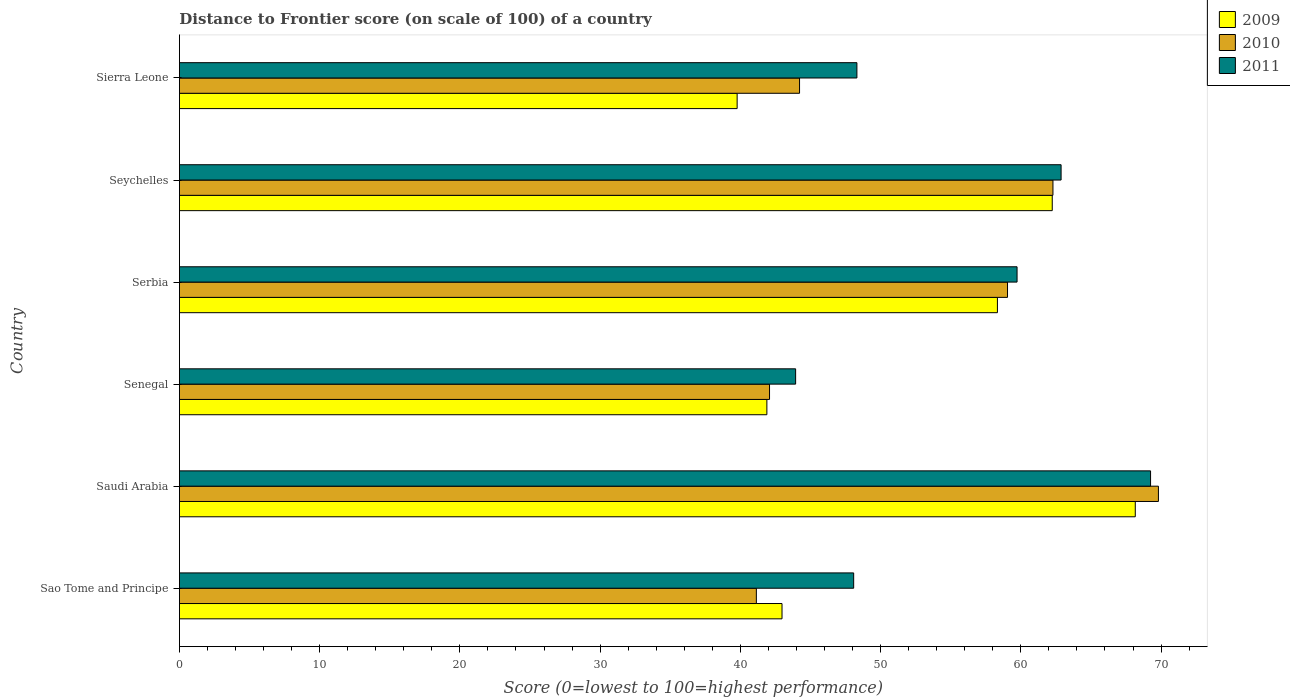How many groups of bars are there?
Give a very brief answer. 6. Are the number of bars on each tick of the Y-axis equal?
Provide a succinct answer. Yes. How many bars are there on the 2nd tick from the top?
Provide a succinct answer. 3. What is the label of the 1st group of bars from the top?
Provide a short and direct response. Sierra Leone. In how many cases, is the number of bars for a given country not equal to the number of legend labels?
Keep it short and to the point. 0. What is the distance to frontier score of in 2010 in Sierra Leone?
Your answer should be compact. 44.22. Across all countries, what is the maximum distance to frontier score of in 2010?
Your answer should be very brief. 69.81. Across all countries, what is the minimum distance to frontier score of in 2009?
Your answer should be very brief. 39.77. In which country was the distance to frontier score of in 2011 maximum?
Make the answer very short. Saudi Arabia. In which country was the distance to frontier score of in 2009 minimum?
Offer a terse response. Sierra Leone. What is the total distance to frontier score of in 2011 in the graph?
Offer a very short reply. 332.18. What is the difference between the distance to frontier score of in 2010 in Saudi Arabia and that in Serbia?
Ensure brevity in your answer.  10.76. What is the difference between the distance to frontier score of in 2010 in Saudi Arabia and the distance to frontier score of in 2009 in Seychelles?
Keep it short and to the point. 7.57. What is the average distance to frontier score of in 2009 per country?
Offer a terse response. 52.23. What is the difference between the distance to frontier score of in 2009 and distance to frontier score of in 2011 in Seychelles?
Your answer should be compact. -0.63. In how many countries, is the distance to frontier score of in 2010 greater than 34 ?
Provide a succinct answer. 6. What is the ratio of the distance to frontier score of in 2011 in Sao Tome and Principe to that in Senegal?
Make the answer very short. 1.09. What is the difference between the highest and the second highest distance to frontier score of in 2010?
Offer a very short reply. 7.52. What is the difference between the highest and the lowest distance to frontier score of in 2009?
Provide a succinct answer. 28.39. What does the 3rd bar from the top in Seychelles represents?
Keep it short and to the point. 2009. Are the values on the major ticks of X-axis written in scientific E-notation?
Your answer should be compact. No. Does the graph contain grids?
Provide a short and direct response. No. Where does the legend appear in the graph?
Make the answer very short. Top right. How are the legend labels stacked?
Give a very brief answer. Vertical. What is the title of the graph?
Ensure brevity in your answer.  Distance to Frontier score (on scale of 100) of a country. Does "2002" appear as one of the legend labels in the graph?
Your answer should be compact. No. What is the label or title of the X-axis?
Provide a short and direct response. Score (0=lowest to 100=highest performance). What is the label or title of the Y-axis?
Offer a terse response. Country. What is the Score (0=lowest to 100=highest performance) in 2009 in Sao Tome and Principe?
Keep it short and to the point. 42.97. What is the Score (0=lowest to 100=highest performance) of 2010 in Sao Tome and Principe?
Your answer should be very brief. 41.14. What is the Score (0=lowest to 100=highest performance) in 2011 in Sao Tome and Principe?
Your response must be concise. 48.08. What is the Score (0=lowest to 100=highest performance) in 2009 in Saudi Arabia?
Offer a very short reply. 68.16. What is the Score (0=lowest to 100=highest performance) of 2010 in Saudi Arabia?
Keep it short and to the point. 69.81. What is the Score (0=lowest to 100=highest performance) in 2011 in Saudi Arabia?
Offer a terse response. 69.25. What is the Score (0=lowest to 100=highest performance) in 2009 in Senegal?
Your answer should be compact. 41.89. What is the Score (0=lowest to 100=highest performance) in 2010 in Senegal?
Your answer should be very brief. 42.08. What is the Score (0=lowest to 100=highest performance) of 2011 in Senegal?
Offer a very short reply. 43.94. What is the Score (0=lowest to 100=highest performance) of 2009 in Serbia?
Your answer should be very brief. 58.33. What is the Score (0=lowest to 100=highest performance) in 2010 in Serbia?
Your answer should be very brief. 59.05. What is the Score (0=lowest to 100=highest performance) in 2011 in Serbia?
Make the answer very short. 59.73. What is the Score (0=lowest to 100=highest performance) of 2009 in Seychelles?
Offer a terse response. 62.24. What is the Score (0=lowest to 100=highest performance) of 2010 in Seychelles?
Provide a short and direct response. 62.29. What is the Score (0=lowest to 100=highest performance) of 2011 in Seychelles?
Offer a terse response. 62.87. What is the Score (0=lowest to 100=highest performance) in 2009 in Sierra Leone?
Your answer should be compact. 39.77. What is the Score (0=lowest to 100=highest performance) of 2010 in Sierra Leone?
Your answer should be compact. 44.22. What is the Score (0=lowest to 100=highest performance) of 2011 in Sierra Leone?
Provide a succinct answer. 48.31. Across all countries, what is the maximum Score (0=lowest to 100=highest performance) of 2009?
Provide a succinct answer. 68.16. Across all countries, what is the maximum Score (0=lowest to 100=highest performance) in 2010?
Your answer should be compact. 69.81. Across all countries, what is the maximum Score (0=lowest to 100=highest performance) in 2011?
Provide a succinct answer. 69.25. Across all countries, what is the minimum Score (0=lowest to 100=highest performance) of 2009?
Offer a very short reply. 39.77. Across all countries, what is the minimum Score (0=lowest to 100=highest performance) in 2010?
Offer a very short reply. 41.14. Across all countries, what is the minimum Score (0=lowest to 100=highest performance) in 2011?
Give a very brief answer. 43.94. What is the total Score (0=lowest to 100=highest performance) of 2009 in the graph?
Your answer should be very brief. 313.36. What is the total Score (0=lowest to 100=highest performance) in 2010 in the graph?
Offer a terse response. 318.59. What is the total Score (0=lowest to 100=highest performance) of 2011 in the graph?
Your answer should be very brief. 332.18. What is the difference between the Score (0=lowest to 100=highest performance) of 2009 in Sao Tome and Principe and that in Saudi Arabia?
Offer a terse response. -25.19. What is the difference between the Score (0=lowest to 100=highest performance) in 2010 in Sao Tome and Principe and that in Saudi Arabia?
Your answer should be compact. -28.67. What is the difference between the Score (0=lowest to 100=highest performance) in 2011 in Sao Tome and Principe and that in Saudi Arabia?
Keep it short and to the point. -21.17. What is the difference between the Score (0=lowest to 100=highest performance) in 2009 in Sao Tome and Principe and that in Senegal?
Provide a short and direct response. 1.08. What is the difference between the Score (0=lowest to 100=highest performance) of 2010 in Sao Tome and Principe and that in Senegal?
Your response must be concise. -0.94. What is the difference between the Score (0=lowest to 100=highest performance) of 2011 in Sao Tome and Principe and that in Senegal?
Keep it short and to the point. 4.14. What is the difference between the Score (0=lowest to 100=highest performance) of 2009 in Sao Tome and Principe and that in Serbia?
Provide a succinct answer. -15.36. What is the difference between the Score (0=lowest to 100=highest performance) of 2010 in Sao Tome and Principe and that in Serbia?
Your answer should be compact. -17.91. What is the difference between the Score (0=lowest to 100=highest performance) of 2011 in Sao Tome and Principe and that in Serbia?
Keep it short and to the point. -11.65. What is the difference between the Score (0=lowest to 100=highest performance) in 2009 in Sao Tome and Principe and that in Seychelles?
Offer a terse response. -19.27. What is the difference between the Score (0=lowest to 100=highest performance) of 2010 in Sao Tome and Principe and that in Seychelles?
Give a very brief answer. -21.15. What is the difference between the Score (0=lowest to 100=highest performance) in 2011 in Sao Tome and Principe and that in Seychelles?
Give a very brief answer. -14.79. What is the difference between the Score (0=lowest to 100=highest performance) in 2010 in Sao Tome and Principe and that in Sierra Leone?
Your answer should be very brief. -3.08. What is the difference between the Score (0=lowest to 100=highest performance) of 2011 in Sao Tome and Principe and that in Sierra Leone?
Provide a short and direct response. -0.23. What is the difference between the Score (0=lowest to 100=highest performance) of 2009 in Saudi Arabia and that in Senegal?
Your answer should be very brief. 26.27. What is the difference between the Score (0=lowest to 100=highest performance) in 2010 in Saudi Arabia and that in Senegal?
Offer a terse response. 27.73. What is the difference between the Score (0=lowest to 100=highest performance) in 2011 in Saudi Arabia and that in Senegal?
Your answer should be very brief. 25.31. What is the difference between the Score (0=lowest to 100=highest performance) of 2009 in Saudi Arabia and that in Serbia?
Your answer should be very brief. 9.83. What is the difference between the Score (0=lowest to 100=highest performance) of 2010 in Saudi Arabia and that in Serbia?
Offer a terse response. 10.76. What is the difference between the Score (0=lowest to 100=highest performance) in 2011 in Saudi Arabia and that in Serbia?
Your response must be concise. 9.52. What is the difference between the Score (0=lowest to 100=highest performance) of 2009 in Saudi Arabia and that in Seychelles?
Offer a terse response. 5.92. What is the difference between the Score (0=lowest to 100=highest performance) in 2010 in Saudi Arabia and that in Seychelles?
Your answer should be compact. 7.52. What is the difference between the Score (0=lowest to 100=highest performance) of 2011 in Saudi Arabia and that in Seychelles?
Ensure brevity in your answer.  6.38. What is the difference between the Score (0=lowest to 100=highest performance) of 2009 in Saudi Arabia and that in Sierra Leone?
Make the answer very short. 28.39. What is the difference between the Score (0=lowest to 100=highest performance) in 2010 in Saudi Arabia and that in Sierra Leone?
Ensure brevity in your answer.  25.59. What is the difference between the Score (0=lowest to 100=highest performance) of 2011 in Saudi Arabia and that in Sierra Leone?
Provide a succinct answer. 20.94. What is the difference between the Score (0=lowest to 100=highest performance) of 2009 in Senegal and that in Serbia?
Keep it short and to the point. -16.44. What is the difference between the Score (0=lowest to 100=highest performance) in 2010 in Senegal and that in Serbia?
Provide a short and direct response. -16.97. What is the difference between the Score (0=lowest to 100=highest performance) in 2011 in Senegal and that in Serbia?
Provide a short and direct response. -15.79. What is the difference between the Score (0=lowest to 100=highest performance) in 2009 in Senegal and that in Seychelles?
Make the answer very short. -20.35. What is the difference between the Score (0=lowest to 100=highest performance) in 2010 in Senegal and that in Seychelles?
Your answer should be very brief. -20.21. What is the difference between the Score (0=lowest to 100=highest performance) of 2011 in Senegal and that in Seychelles?
Make the answer very short. -18.93. What is the difference between the Score (0=lowest to 100=highest performance) in 2009 in Senegal and that in Sierra Leone?
Offer a terse response. 2.12. What is the difference between the Score (0=lowest to 100=highest performance) in 2010 in Senegal and that in Sierra Leone?
Your answer should be very brief. -2.14. What is the difference between the Score (0=lowest to 100=highest performance) in 2011 in Senegal and that in Sierra Leone?
Make the answer very short. -4.37. What is the difference between the Score (0=lowest to 100=highest performance) of 2009 in Serbia and that in Seychelles?
Offer a terse response. -3.91. What is the difference between the Score (0=lowest to 100=highest performance) in 2010 in Serbia and that in Seychelles?
Offer a very short reply. -3.24. What is the difference between the Score (0=lowest to 100=highest performance) in 2011 in Serbia and that in Seychelles?
Make the answer very short. -3.14. What is the difference between the Score (0=lowest to 100=highest performance) in 2009 in Serbia and that in Sierra Leone?
Give a very brief answer. 18.56. What is the difference between the Score (0=lowest to 100=highest performance) of 2010 in Serbia and that in Sierra Leone?
Offer a terse response. 14.83. What is the difference between the Score (0=lowest to 100=highest performance) in 2011 in Serbia and that in Sierra Leone?
Ensure brevity in your answer.  11.42. What is the difference between the Score (0=lowest to 100=highest performance) in 2009 in Seychelles and that in Sierra Leone?
Provide a short and direct response. 22.47. What is the difference between the Score (0=lowest to 100=highest performance) of 2010 in Seychelles and that in Sierra Leone?
Your response must be concise. 18.07. What is the difference between the Score (0=lowest to 100=highest performance) in 2011 in Seychelles and that in Sierra Leone?
Your answer should be compact. 14.56. What is the difference between the Score (0=lowest to 100=highest performance) in 2009 in Sao Tome and Principe and the Score (0=lowest to 100=highest performance) in 2010 in Saudi Arabia?
Offer a terse response. -26.84. What is the difference between the Score (0=lowest to 100=highest performance) of 2009 in Sao Tome and Principe and the Score (0=lowest to 100=highest performance) of 2011 in Saudi Arabia?
Your answer should be compact. -26.28. What is the difference between the Score (0=lowest to 100=highest performance) of 2010 in Sao Tome and Principe and the Score (0=lowest to 100=highest performance) of 2011 in Saudi Arabia?
Ensure brevity in your answer.  -28.11. What is the difference between the Score (0=lowest to 100=highest performance) in 2009 in Sao Tome and Principe and the Score (0=lowest to 100=highest performance) in 2010 in Senegal?
Keep it short and to the point. 0.89. What is the difference between the Score (0=lowest to 100=highest performance) of 2009 in Sao Tome and Principe and the Score (0=lowest to 100=highest performance) of 2011 in Senegal?
Your answer should be very brief. -0.97. What is the difference between the Score (0=lowest to 100=highest performance) of 2010 in Sao Tome and Principe and the Score (0=lowest to 100=highest performance) of 2011 in Senegal?
Your answer should be very brief. -2.8. What is the difference between the Score (0=lowest to 100=highest performance) of 2009 in Sao Tome and Principe and the Score (0=lowest to 100=highest performance) of 2010 in Serbia?
Your response must be concise. -16.08. What is the difference between the Score (0=lowest to 100=highest performance) of 2009 in Sao Tome and Principe and the Score (0=lowest to 100=highest performance) of 2011 in Serbia?
Your answer should be very brief. -16.76. What is the difference between the Score (0=lowest to 100=highest performance) of 2010 in Sao Tome and Principe and the Score (0=lowest to 100=highest performance) of 2011 in Serbia?
Give a very brief answer. -18.59. What is the difference between the Score (0=lowest to 100=highest performance) of 2009 in Sao Tome and Principe and the Score (0=lowest to 100=highest performance) of 2010 in Seychelles?
Give a very brief answer. -19.32. What is the difference between the Score (0=lowest to 100=highest performance) in 2009 in Sao Tome and Principe and the Score (0=lowest to 100=highest performance) in 2011 in Seychelles?
Make the answer very short. -19.9. What is the difference between the Score (0=lowest to 100=highest performance) of 2010 in Sao Tome and Principe and the Score (0=lowest to 100=highest performance) of 2011 in Seychelles?
Offer a very short reply. -21.73. What is the difference between the Score (0=lowest to 100=highest performance) of 2009 in Sao Tome and Principe and the Score (0=lowest to 100=highest performance) of 2010 in Sierra Leone?
Offer a very short reply. -1.25. What is the difference between the Score (0=lowest to 100=highest performance) in 2009 in Sao Tome and Principe and the Score (0=lowest to 100=highest performance) in 2011 in Sierra Leone?
Your response must be concise. -5.34. What is the difference between the Score (0=lowest to 100=highest performance) in 2010 in Sao Tome and Principe and the Score (0=lowest to 100=highest performance) in 2011 in Sierra Leone?
Provide a short and direct response. -7.17. What is the difference between the Score (0=lowest to 100=highest performance) in 2009 in Saudi Arabia and the Score (0=lowest to 100=highest performance) in 2010 in Senegal?
Your response must be concise. 26.08. What is the difference between the Score (0=lowest to 100=highest performance) of 2009 in Saudi Arabia and the Score (0=lowest to 100=highest performance) of 2011 in Senegal?
Offer a very short reply. 24.22. What is the difference between the Score (0=lowest to 100=highest performance) of 2010 in Saudi Arabia and the Score (0=lowest to 100=highest performance) of 2011 in Senegal?
Your answer should be very brief. 25.87. What is the difference between the Score (0=lowest to 100=highest performance) of 2009 in Saudi Arabia and the Score (0=lowest to 100=highest performance) of 2010 in Serbia?
Your answer should be very brief. 9.11. What is the difference between the Score (0=lowest to 100=highest performance) of 2009 in Saudi Arabia and the Score (0=lowest to 100=highest performance) of 2011 in Serbia?
Make the answer very short. 8.43. What is the difference between the Score (0=lowest to 100=highest performance) of 2010 in Saudi Arabia and the Score (0=lowest to 100=highest performance) of 2011 in Serbia?
Provide a succinct answer. 10.08. What is the difference between the Score (0=lowest to 100=highest performance) of 2009 in Saudi Arabia and the Score (0=lowest to 100=highest performance) of 2010 in Seychelles?
Make the answer very short. 5.87. What is the difference between the Score (0=lowest to 100=highest performance) of 2009 in Saudi Arabia and the Score (0=lowest to 100=highest performance) of 2011 in Seychelles?
Provide a short and direct response. 5.29. What is the difference between the Score (0=lowest to 100=highest performance) of 2010 in Saudi Arabia and the Score (0=lowest to 100=highest performance) of 2011 in Seychelles?
Your response must be concise. 6.94. What is the difference between the Score (0=lowest to 100=highest performance) in 2009 in Saudi Arabia and the Score (0=lowest to 100=highest performance) in 2010 in Sierra Leone?
Provide a succinct answer. 23.94. What is the difference between the Score (0=lowest to 100=highest performance) of 2009 in Saudi Arabia and the Score (0=lowest to 100=highest performance) of 2011 in Sierra Leone?
Your response must be concise. 19.85. What is the difference between the Score (0=lowest to 100=highest performance) of 2009 in Senegal and the Score (0=lowest to 100=highest performance) of 2010 in Serbia?
Provide a short and direct response. -17.16. What is the difference between the Score (0=lowest to 100=highest performance) of 2009 in Senegal and the Score (0=lowest to 100=highest performance) of 2011 in Serbia?
Your answer should be compact. -17.84. What is the difference between the Score (0=lowest to 100=highest performance) in 2010 in Senegal and the Score (0=lowest to 100=highest performance) in 2011 in Serbia?
Ensure brevity in your answer.  -17.65. What is the difference between the Score (0=lowest to 100=highest performance) of 2009 in Senegal and the Score (0=lowest to 100=highest performance) of 2010 in Seychelles?
Provide a short and direct response. -20.4. What is the difference between the Score (0=lowest to 100=highest performance) in 2009 in Senegal and the Score (0=lowest to 100=highest performance) in 2011 in Seychelles?
Give a very brief answer. -20.98. What is the difference between the Score (0=lowest to 100=highest performance) in 2010 in Senegal and the Score (0=lowest to 100=highest performance) in 2011 in Seychelles?
Offer a very short reply. -20.79. What is the difference between the Score (0=lowest to 100=highest performance) of 2009 in Senegal and the Score (0=lowest to 100=highest performance) of 2010 in Sierra Leone?
Ensure brevity in your answer.  -2.33. What is the difference between the Score (0=lowest to 100=highest performance) in 2009 in Senegal and the Score (0=lowest to 100=highest performance) in 2011 in Sierra Leone?
Keep it short and to the point. -6.42. What is the difference between the Score (0=lowest to 100=highest performance) of 2010 in Senegal and the Score (0=lowest to 100=highest performance) of 2011 in Sierra Leone?
Make the answer very short. -6.23. What is the difference between the Score (0=lowest to 100=highest performance) of 2009 in Serbia and the Score (0=lowest to 100=highest performance) of 2010 in Seychelles?
Keep it short and to the point. -3.96. What is the difference between the Score (0=lowest to 100=highest performance) in 2009 in Serbia and the Score (0=lowest to 100=highest performance) in 2011 in Seychelles?
Provide a short and direct response. -4.54. What is the difference between the Score (0=lowest to 100=highest performance) in 2010 in Serbia and the Score (0=lowest to 100=highest performance) in 2011 in Seychelles?
Offer a terse response. -3.82. What is the difference between the Score (0=lowest to 100=highest performance) of 2009 in Serbia and the Score (0=lowest to 100=highest performance) of 2010 in Sierra Leone?
Provide a succinct answer. 14.11. What is the difference between the Score (0=lowest to 100=highest performance) of 2009 in Serbia and the Score (0=lowest to 100=highest performance) of 2011 in Sierra Leone?
Your answer should be very brief. 10.02. What is the difference between the Score (0=lowest to 100=highest performance) of 2010 in Serbia and the Score (0=lowest to 100=highest performance) of 2011 in Sierra Leone?
Your answer should be very brief. 10.74. What is the difference between the Score (0=lowest to 100=highest performance) in 2009 in Seychelles and the Score (0=lowest to 100=highest performance) in 2010 in Sierra Leone?
Your response must be concise. 18.02. What is the difference between the Score (0=lowest to 100=highest performance) of 2009 in Seychelles and the Score (0=lowest to 100=highest performance) of 2011 in Sierra Leone?
Give a very brief answer. 13.93. What is the difference between the Score (0=lowest to 100=highest performance) of 2010 in Seychelles and the Score (0=lowest to 100=highest performance) of 2011 in Sierra Leone?
Your answer should be very brief. 13.98. What is the average Score (0=lowest to 100=highest performance) in 2009 per country?
Ensure brevity in your answer.  52.23. What is the average Score (0=lowest to 100=highest performance) of 2010 per country?
Provide a succinct answer. 53.1. What is the average Score (0=lowest to 100=highest performance) in 2011 per country?
Ensure brevity in your answer.  55.36. What is the difference between the Score (0=lowest to 100=highest performance) in 2009 and Score (0=lowest to 100=highest performance) in 2010 in Sao Tome and Principe?
Give a very brief answer. 1.83. What is the difference between the Score (0=lowest to 100=highest performance) of 2009 and Score (0=lowest to 100=highest performance) of 2011 in Sao Tome and Principe?
Provide a short and direct response. -5.11. What is the difference between the Score (0=lowest to 100=highest performance) in 2010 and Score (0=lowest to 100=highest performance) in 2011 in Sao Tome and Principe?
Make the answer very short. -6.94. What is the difference between the Score (0=lowest to 100=highest performance) in 2009 and Score (0=lowest to 100=highest performance) in 2010 in Saudi Arabia?
Offer a terse response. -1.65. What is the difference between the Score (0=lowest to 100=highest performance) in 2009 and Score (0=lowest to 100=highest performance) in 2011 in Saudi Arabia?
Give a very brief answer. -1.09. What is the difference between the Score (0=lowest to 100=highest performance) of 2010 and Score (0=lowest to 100=highest performance) of 2011 in Saudi Arabia?
Offer a terse response. 0.56. What is the difference between the Score (0=lowest to 100=highest performance) of 2009 and Score (0=lowest to 100=highest performance) of 2010 in Senegal?
Offer a terse response. -0.19. What is the difference between the Score (0=lowest to 100=highest performance) of 2009 and Score (0=lowest to 100=highest performance) of 2011 in Senegal?
Keep it short and to the point. -2.05. What is the difference between the Score (0=lowest to 100=highest performance) in 2010 and Score (0=lowest to 100=highest performance) in 2011 in Senegal?
Offer a terse response. -1.86. What is the difference between the Score (0=lowest to 100=highest performance) of 2009 and Score (0=lowest to 100=highest performance) of 2010 in Serbia?
Keep it short and to the point. -0.72. What is the difference between the Score (0=lowest to 100=highest performance) in 2010 and Score (0=lowest to 100=highest performance) in 2011 in Serbia?
Provide a short and direct response. -0.68. What is the difference between the Score (0=lowest to 100=highest performance) in 2009 and Score (0=lowest to 100=highest performance) in 2011 in Seychelles?
Provide a succinct answer. -0.63. What is the difference between the Score (0=lowest to 100=highest performance) in 2010 and Score (0=lowest to 100=highest performance) in 2011 in Seychelles?
Your response must be concise. -0.58. What is the difference between the Score (0=lowest to 100=highest performance) in 2009 and Score (0=lowest to 100=highest performance) in 2010 in Sierra Leone?
Offer a terse response. -4.45. What is the difference between the Score (0=lowest to 100=highest performance) in 2009 and Score (0=lowest to 100=highest performance) in 2011 in Sierra Leone?
Your response must be concise. -8.54. What is the difference between the Score (0=lowest to 100=highest performance) of 2010 and Score (0=lowest to 100=highest performance) of 2011 in Sierra Leone?
Keep it short and to the point. -4.09. What is the ratio of the Score (0=lowest to 100=highest performance) in 2009 in Sao Tome and Principe to that in Saudi Arabia?
Make the answer very short. 0.63. What is the ratio of the Score (0=lowest to 100=highest performance) of 2010 in Sao Tome and Principe to that in Saudi Arabia?
Your answer should be compact. 0.59. What is the ratio of the Score (0=lowest to 100=highest performance) of 2011 in Sao Tome and Principe to that in Saudi Arabia?
Keep it short and to the point. 0.69. What is the ratio of the Score (0=lowest to 100=highest performance) of 2009 in Sao Tome and Principe to that in Senegal?
Offer a very short reply. 1.03. What is the ratio of the Score (0=lowest to 100=highest performance) of 2010 in Sao Tome and Principe to that in Senegal?
Your response must be concise. 0.98. What is the ratio of the Score (0=lowest to 100=highest performance) of 2011 in Sao Tome and Principe to that in Senegal?
Provide a short and direct response. 1.09. What is the ratio of the Score (0=lowest to 100=highest performance) of 2009 in Sao Tome and Principe to that in Serbia?
Keep it short and to the point. 0.74. What is the ratio of the Score (0=lowest to 100=highest performance) in 2010 in Sao Tome and Principe to that in Serbia?
Your answer should be compact. 0.7. What is the ratio of the Score (0=lowest to 100=highest performance) of 2011 in Sao Tome and Principe to that in Serbia?
Your response must be concise. 0.81. What is the ratio of the Score (0=lowest to 100=highest performance) in 2009 in Sao Tome and Principe to that in Seychelles?
Offer a very short reply. 0.69. What is the ratio of the Score (0=lowest to 100=highest performance) in 2010 in Sao Tome and Principe to that in Seychelles?
Your response must be concise. 0.66. What is the ratio of the Score (0=lowest to 100=highest performance) of 2011 in Sao Tome and Principe to that in Seychelles?
Keep it short and to the point. 0.76. What is the ratio of the Score (0=lowest to 100=highest performance) in 2009 in Sao Tome and Principe to that in Sierra Leone?
Offer a terse response. 1.08. What is the ratio of the Score (0=lowest to 100=highest performance) of 2010 in Sao Tome and Principe to that in Sierra Leone?
Your response must be concise. 0.93. What is the ratio of the Score (0=lowest to 100=highest performance) of 2011 in Sao Tome and Principe to that in Sierra Leone?
Your answer should be compact. 1. What is the ratio of the Score (0=lowest to 100=highest performance) of 2009 in Saudi Arabia to that in Senegal?
Your response must be concise. 1.63. What is the ratio of the Score (0=lowest to 100=highest performance) of 2010 in Saudi Arabia to that in Senegal?
Provide a succinct answer. 1.66. What is the ratio of the Score (0=lowest to 100=highest performance) of 2011 in Saudi Arabia to that in Senegal?
Provide a short and direct response. 1.58. What is the ratio of the Score (0=lowest to 100=highest performance) in 2009 in Saudi Arabia to that in Serbia?
Offer a terse response. 1.17. What is the ratio of the Score (0=lowest to 100=highest performance) in 2010 in Saudi Arabia to that in Serbia?
Ensure brevity in your answer.  1.18. What is the ratio of the Score (0=lowest to 100=highest performance) in 2011 in Saudi Arabia to that in Serbia?
Provide a succinct answer. 1.16. What is the ratio of the Score (0=lowest to 100=highest performance) in 2009 in Saudi Arabia to that in Seychelles?
Provide a succinct answer. 1.1. What is the ratio of the Score (0=lowest to 100=highest performance) of 2010 in Saudi Arabia to that in Seychelles?
Your response must be concise. 1.12. What is the ratio of the Score (0=lowest to 100=highest performance) of 2011 in Saudi Arabia to that in Seychelles?
Offer a very short reply. 1.1. What is the ratio of the Score (0=lowest to 100=highest performance) of 2009 in Saudi Arabia to that in Sierra Leone?
Your answer should be very brief. 1.71. What is the ratio of the Score (0=lowest to 100=highest performance) of 2010 in Saudi Arabia to that in Sierra Leone?
Provide a short and direct response. 1.58. What is the ratio of the Score (0=lowest to 100=highest performance) of 2011 in Saudi Arabia to that in Sierra Leone?
Give a very brief answer. 1.43. What is the ratio of the Score (0=lowest to 100=highest performance) of 2009 in Senegal to that in Serbia?
Provide a succinct answer. 0.72. What is the ratio of the Score (0=lowest to 100=highest performance) of 2010 in Senegal to that in Serbia?
Provide a short and direct response. 0.71. What is the ratio of the Score (0=lowest to 100=highest performance) of 2011 in Senegal to that in Serbia?
Provide a succinct answer. 0.74. What is the ratio of the Score (0=lowest to 100=highest performance) in 2009 in Senegal to that in Seychelles?
Ensure brevity in your answer.  0.67. What is the ratio of the Score (0=lowest to 100=highest performance) in 2010 in Senegal to that in Seychelles?
Provide a short and direct response. 0.68. What is the ratio of the Score (0=lowest to 100=highest performance) of 2011 in Senegal to that in Seychelles?
Give a very brief answer. 0.7. What is the ratio of the Score (0=lowest to 100=highest performance) in 2009 in Senegal to that in Sierra Leone?
Ensure brevity in your answer.  1.05. What is the ratio of the Score (0=lowest to 100=highest performance) in 2010 in Senegal to that in Sierra Leone?
Your answer should be compact. 0.95. What is the ratio of the Score (0=lowest to 100=highest performance) of 2011 in Senegal to that in Sierra Leone?
Your answer should be very brief. 0.91. What is the ratio of the Score (0=lowest to 100=highest performance) in 2009 in Serbia to that in Seychelles?
Your response must be concise. 0.94. What is the ratio of the Score (0=lowest to 100=highest performance) of 2010 in Serbia to that in Seychelles?
Offer a terse response. 0.95. What is the ratio of the Score (0=lowest to 100=highest performance) in 2011 in Serbia to that in Seychelles?
Offer a terse response. 0.95. What is the ratio of the Score (0=lowest to 100=highest performance) in 2009 in Serbia to that in Sierra Leone?
Keep it short and to the point. 1.47. What is the ratio of the Score (0=lowest to 100=highest performance) of 2010 in Serbia to that in Sierra Leone?
Provide a short and direct response. 1.34. What is the ratio of the Score (0=lowest to 100=highest performance) in 2011 in Serbia to that in Sierra Leone?
Your answer should be compact. 1.24. What is the ratio of the Score (0=lowest to 100=highest performance) of 2009 in Seychelles to that in Sierra Leone?
Your answer should be very brief. 1.56. What is the ratio of the Score (0=lowest to 100=highest performance) in 2010 in Seychelles to that in Sierra Leone?
Offer a terse response. 1.41. What is the ratio of the Score (0=lowest to 100=highest performance) in 2011 in Seychelles to that in Sierra Leone?
Provide a succinct answer. 1.3. What is the difference between the highest and the second highest Score (0=lowest to 100=highest performance) of 2009?
Provide a short and direct response. 5.92. What is the difference between the highest and the second highest Score (0=lowest to 100=highest performance) in 2010?
Keep it short and to the point. 7.52. What is the difference between the highest and the second highest Score (0=lowest to 100=highest performance) in 2011?
Give a very brief answer. 6.38. What is the difference between the highest and the lowest Score (0=lowest to 100=highest performance) in 2009?
Offer a very short reply. 28.39. What is the difference between the highest and the lowest Score (0=lowest to 100=highest performance) in 2010?
Give a very brief answer. 28.67. What is the difference between the highest and the lowest Score (0=lowest to 100=highest performance) of 2011?
Offer a terse response. 25.31. 